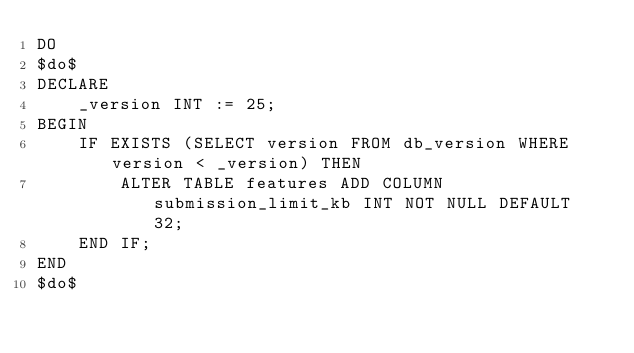<code> <loc_0><loc_0><loc_500><loc_500><_SQL_>DO
$do$
DECLARE
    _version INT := 25;
BEGIN
    IF EXISTS (SELECT version FROM db_version WHERE version < _version) THEN
        ALTER TABLE features ADD COLUMN submission_limit_kb INT NOT NULL DEFAULT 32;
    END IF;
END
$do$
</code> 